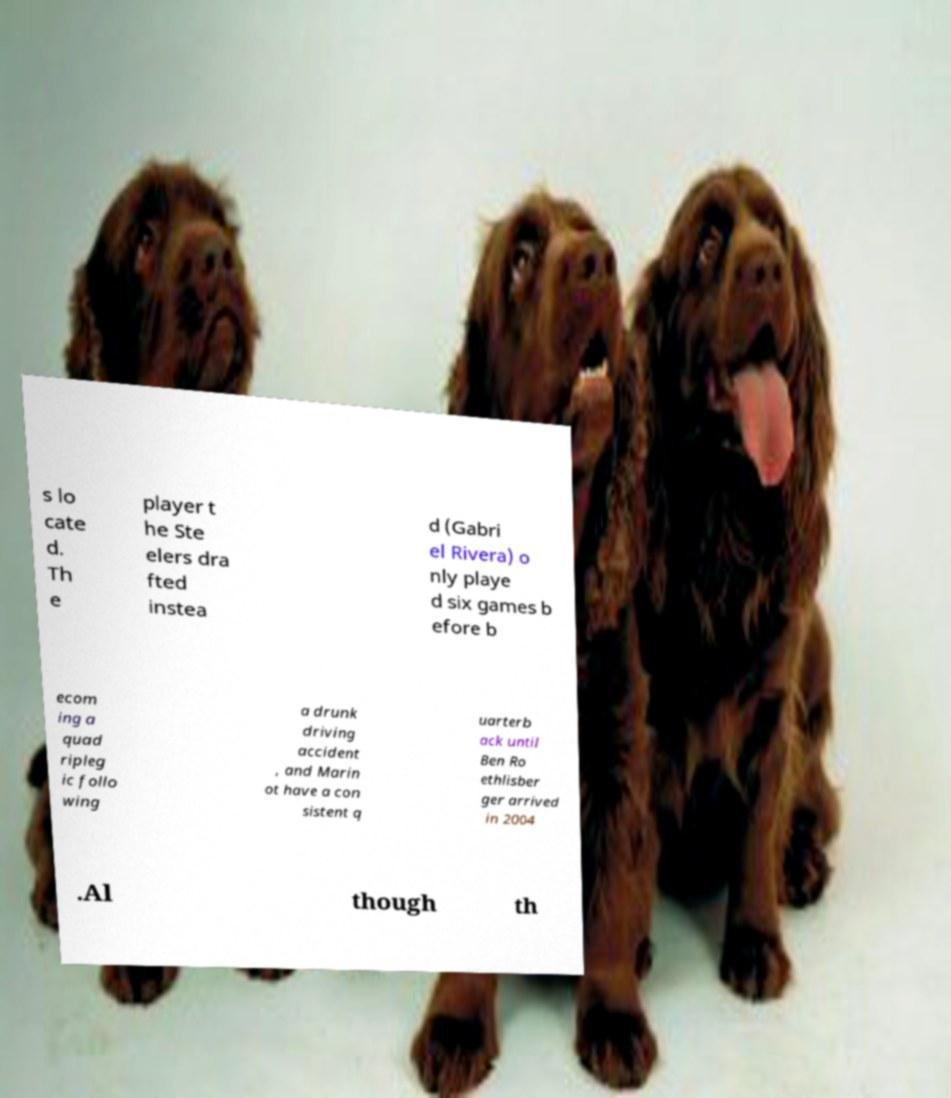Please identify and transcribe the text found in this image. s lo cate d. Th e player t he Ste elers dra fted instea d (Gabri el Rivera) o nly playe d six games b efore b ecom ing a quad ripleg ic follo wing a drunk driving accident , and Marin ot have a con sistent q uarterb ack until Ben Ro ethlisber ger arrived in 2004 .Al though th 